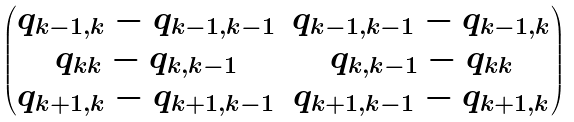Convert formula to latex. <formula><loc_0><loc_0><loc_500><loc_500>\begin{pmatrix} q _ { k - 1 , k } - q _ { k - 1 , k - 1 } & q _ { k - 1 , k - 1 } - q _ { k - 1 , k } \\ q _ { k k } - q _ { k , k - 1 } & q _ { k , k - 1 } - q _ { k k } \\ q _ { k + 1 , k } - q _ { k + 1 , k - 1 } & q _ { k + 1 , k - 1 } - q _ { k + 1 , k } \\ \end{pmatrix}</formula> 